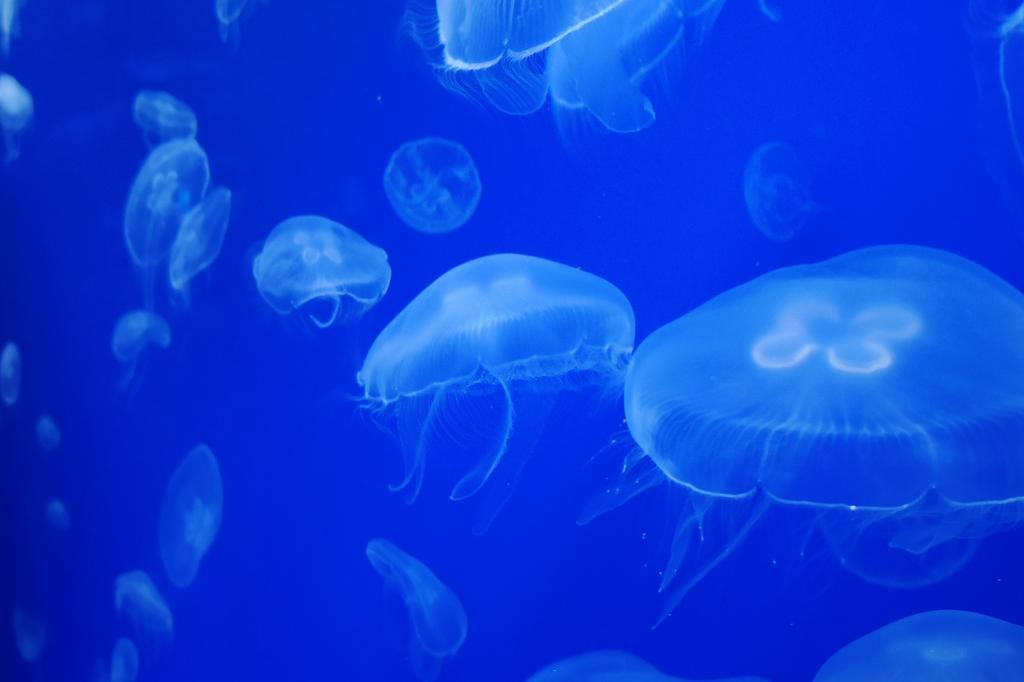Could you give a brief overview of what you see in this image? In this picture we can see jellyfishes are present in water. 